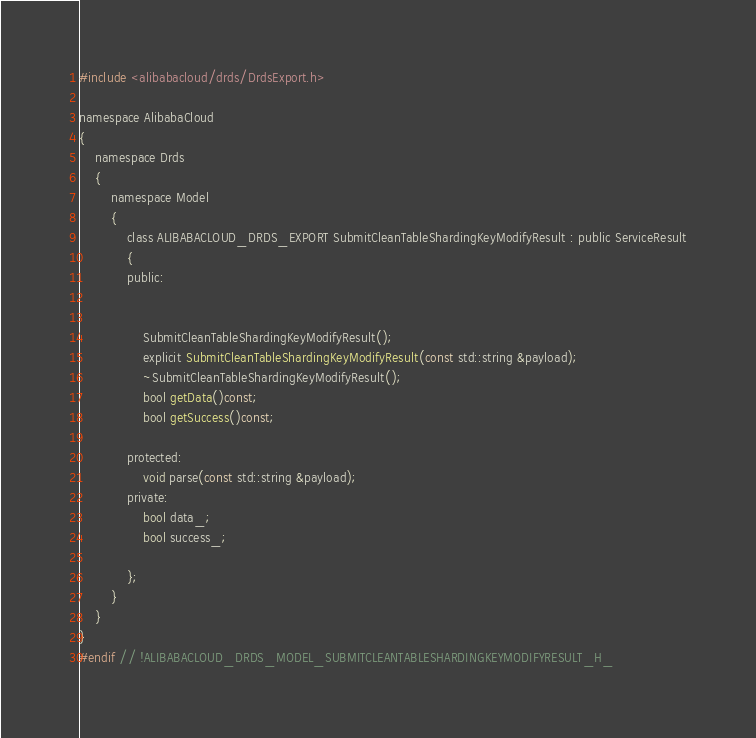<code> <loc_0><loc_0><loc_500><loc_500><_C_>#include <alibabacloud/drds/DrdsExport.h>

namespace AlibabaCloud
{
	namespace Drds
	{
		namespace Model
		{
			class ALIBABACLOUD_DRDS_EXPORT SubmitCleanTableShardingKeyModifyResult : public ServiceResult
			{
			public:


				SubmitCleanTableShardingKeyModifyResult();
				explicit SubmitCleanTableShardingKeyModifyResult(const std::string &payload);
				~SubmitCleanTableShardingKeyModifyResult();
				bool getData()const;
				bool getSuccess()const;

			protected:
				void parse(const std::string &payload);
			private:
				bool data_;
				bool success_;

			};
		}
	}
}
#endif // !ALIBABACLOUD_DRDS_MODEL_SUBMITCLEANTABLESHARDINGKEYMODIFYRESULT_H_</code> 